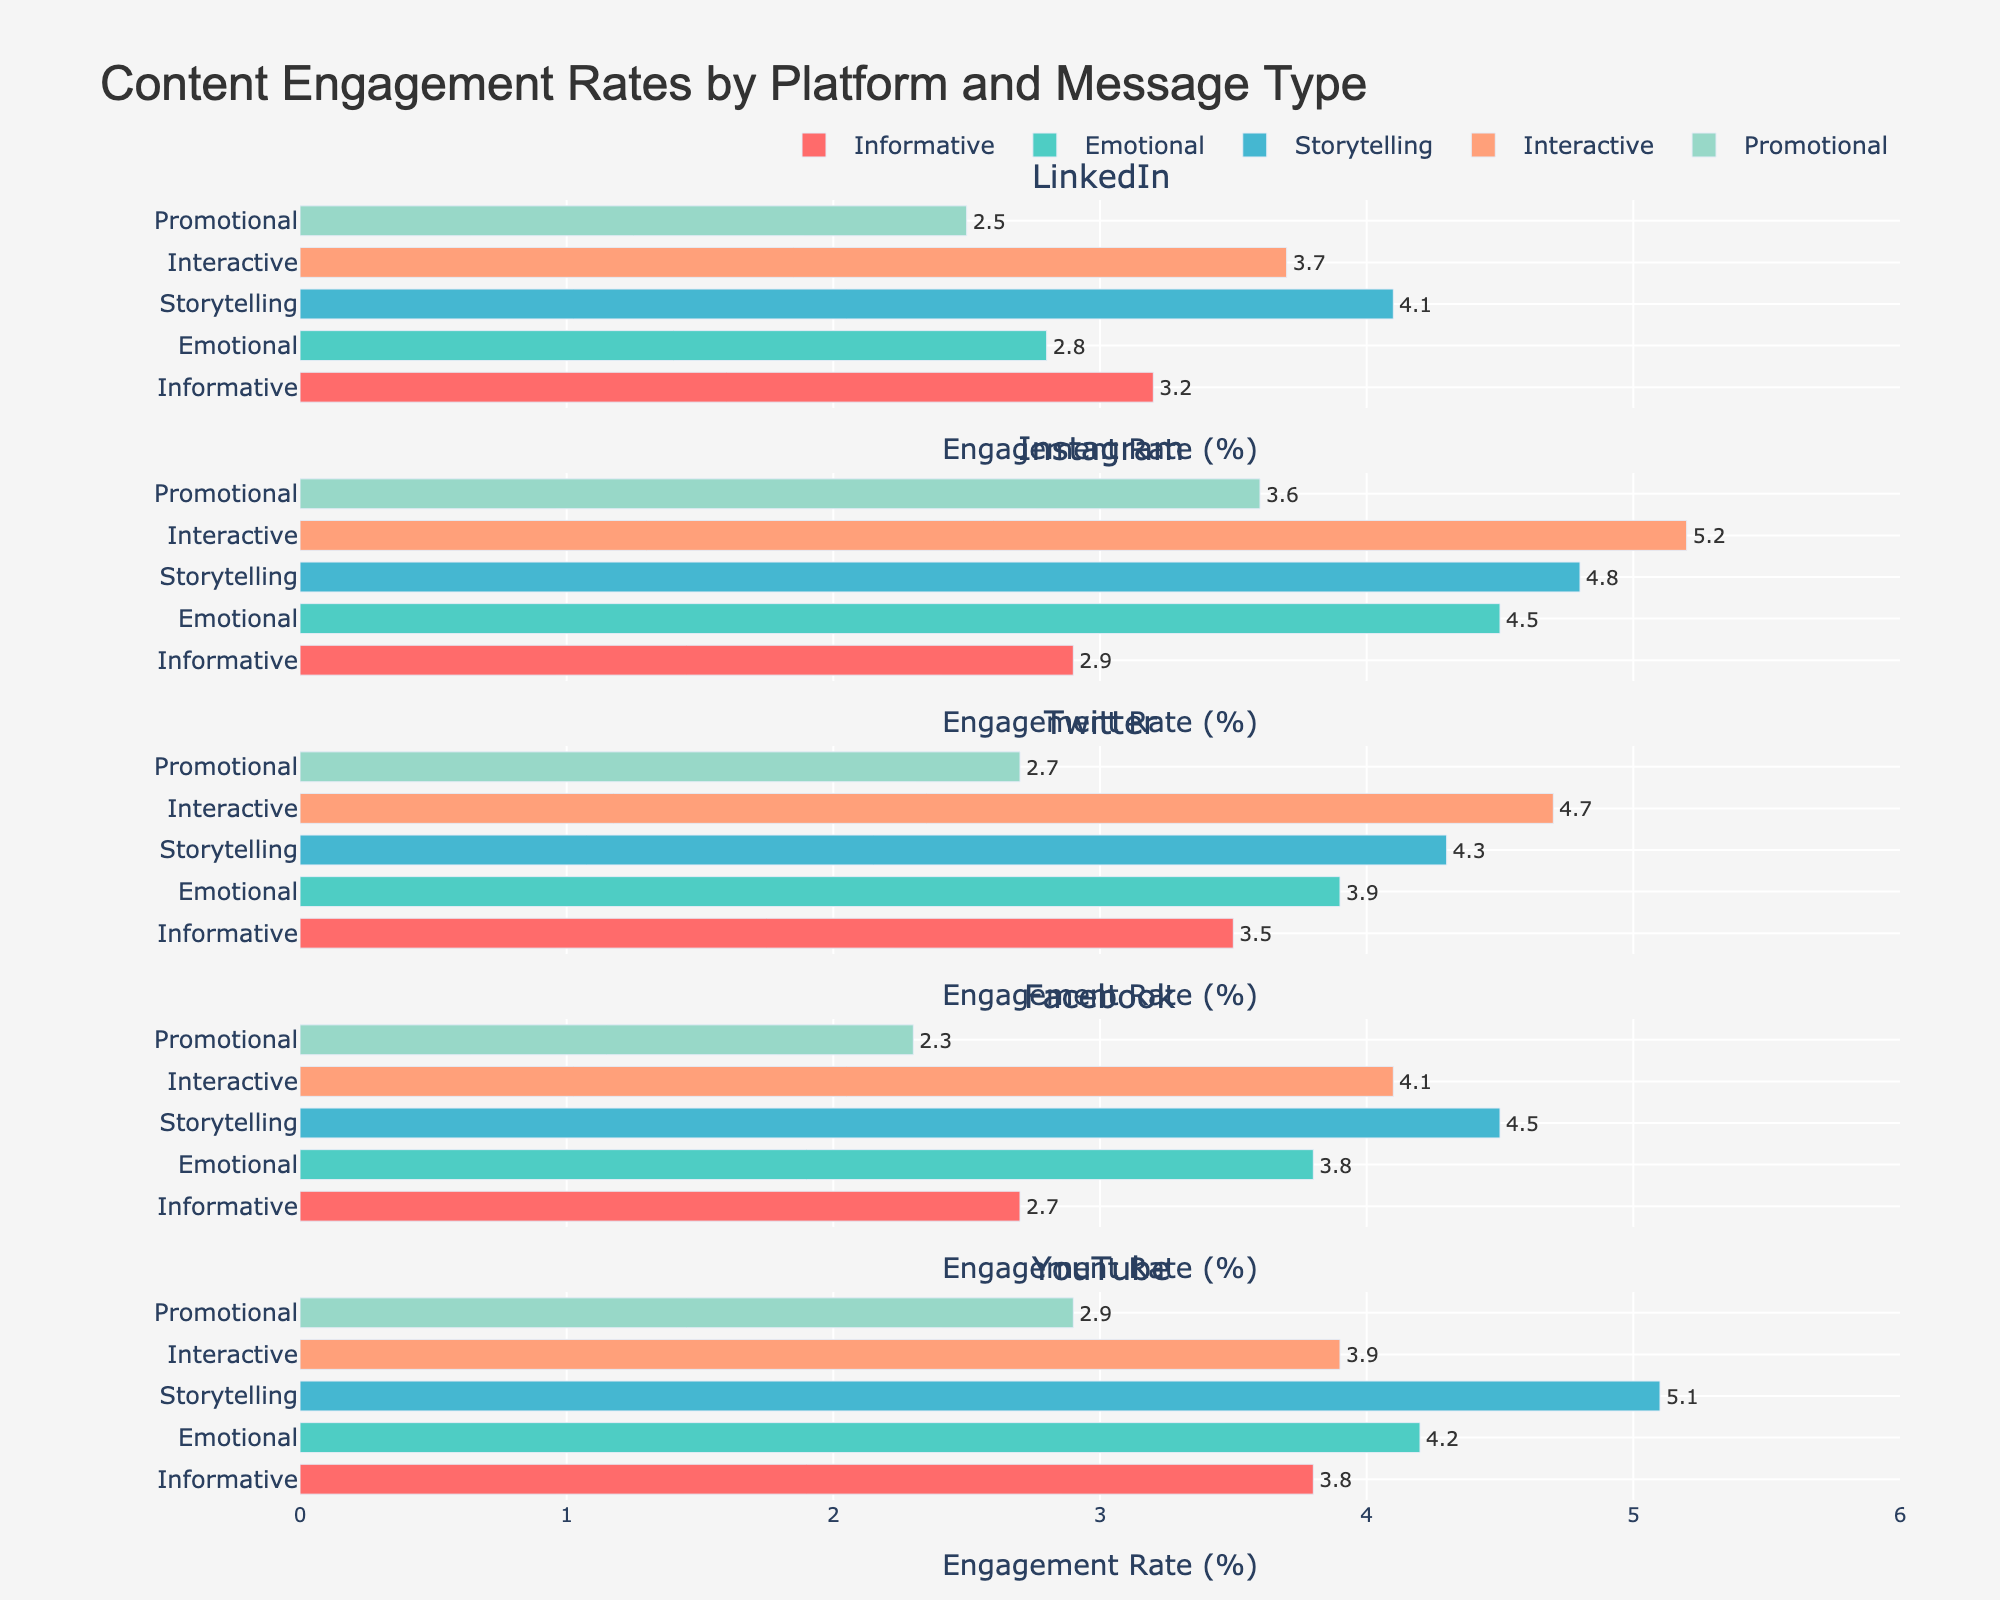Which platform has the highest engagement rate for Interactive messages? The Interactive message type for each platform can be found on the respective bar for 'Interactive' in each subplot. The highest engagement rate for Interactive messages is on Instagram, which is 5.2.
Answer: Instagram Which message type has the lowest engagement rate on Twitter? Look at the Twitter subplot and identify the bar with the smallest value. The bar representing Promotional messages has the lowest engagement rate, which is 2.7.
Answer: Promotional What's the difference in engagement rate for Storytelling messages between YouTube and Facebook? Find the engagement rates for Storytelling on YouTube (5.1) and Facebook (4.5). Then subtract the latter from the former: 5.1 - 4.5 = 0.6.
Answer: 0.6 Which message type generally has the highest engagement rates across all platforms? Look at each message type across all platforms. Storytelling messages consistently have high engagement rates, with values of 4.1, 4.8, 4.3, 4.5, and 5.1 across the platforms.
Answer: Storytelling Compare the engagement rates for Emotional messages on LinkedIn and Instagram. Which is higher and by how much? The engagement rate for Emotional messages on LinkedIn is 2.8 and on Instagram is 4.5. Subtract the two to find the difference: 4.5 - 2.8 = 1.7. Instagram's engagement rate is higher by 1.7.
Answer: Instagram by 1.7 What is the average engagement rate of Promotional messages across all platforms? Sum the engagement rates of Promotional messages across all platforms and divide by the number of platforms: (2.5 + 3.6 + 2.7 + 2.3 + 2.9) / 5. The sum is 14, and 14 / 5 = 2.8.
Answer: 2.8 Rank the platforms from highest to lowest engagement rate for Informative messages. The engagement rates for Informative messages are: LinkedIn (3.2), Instagram (2.9), Twitter (3.5), Facebook (2.7), YouTube (3.8). Ranking them: YouTube, Twitter, LinkedIn, Instagram, Facebook.
Answer: YouTube, Twitter, LinkedIn, Instagram, Facebook Which platform has the lowest variance in engagement rates across all message types? Calculate the variance for engagement rates across all message types for each platform. The platform with the lowest variance has the data points closest to their average. From observation, LinkedIn has relatively similar values (3.2, 2.8, 4.1, 3.7, 2.5).
Answer: LinkedIn 